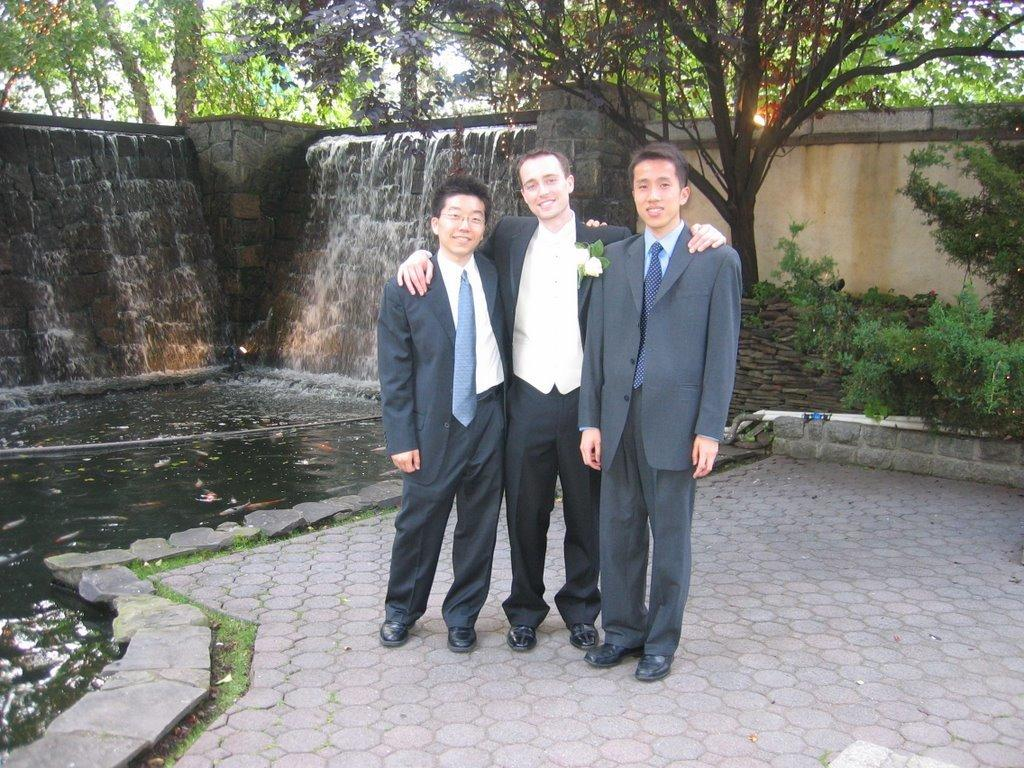What are the people in the image doing? The persons standing in the center of the image are smiling. What can be seen in the background of the image? There are trees in the background of the image. What is in the center of the image besides the people? There is water in the center of the image. What type of breakfast is being served on the coat in the image? There is no coat or breakfast present in the image. What force is causing the water to move in the image? The provided facts do not mention any force causing the water to move in the image. 